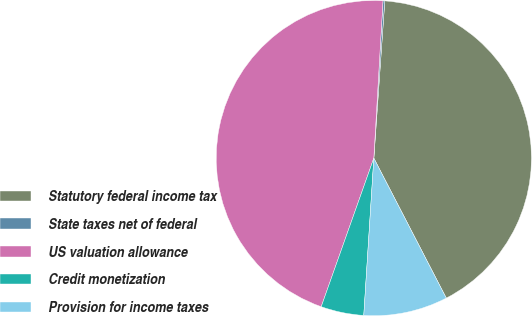Convert chart. <chart><loc_0><loc_0><loc_500><loc_500><pie_chart><fcel>Statutory federal income tax<fcel>State taxes net of federal<fcel>US valuation allowance<fcel>Credit monetization<fcel>Provision for income taxes<nl><fcel>41.29%<fcel>0.18%<fcel>45.51%<fcel>4.4%<fcel>8.62%<nl></chart> 